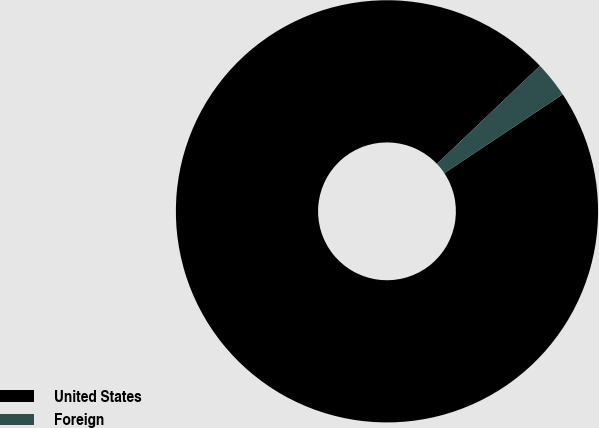<chart> <loc_0><loc_0><loc_500><loc_500><pie_chart><fcel>United States<fcel>Foreign<nl><fcel>97.25%<fcel>2.75%<nl></chart> 